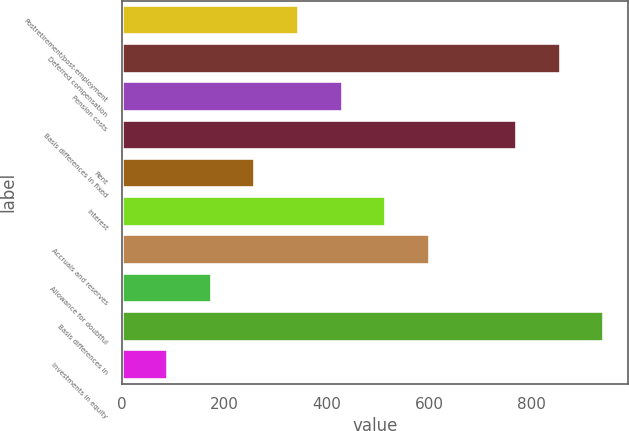<chart> <loc_0><loc_0><loc_500><loc_500><bar_chart><fcel>Postretirement/post-employment<fcel>Deferred compensation<fcel>Pension costs<fcel>Basis differences in fixed<fcel>Rent<fcel>Interest<fcel>Accruals and reserves<fcel>Allowance for doubtful<fcel>Basis differences in<fcel>Investments in equity<nl><fcel>346.04<fcel>857<fcel>431.2<fcel>771.84<fcel>260.88<fcel>516.36<fcel>601.52<fcel>175.72<fcel>942.16<fcel>90.56<nl></chart> 